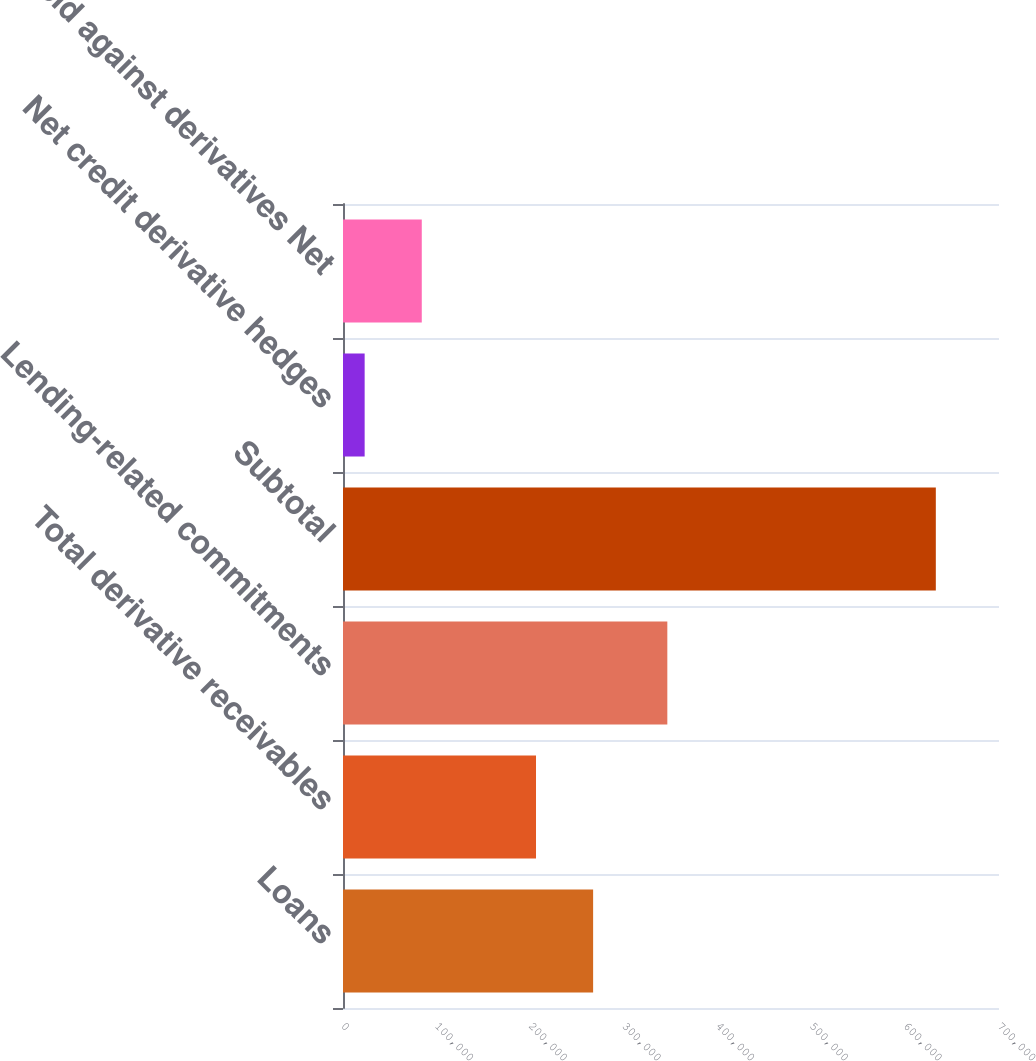Convert chart. <chart><loc_0><loc_0><loc_500><loc_500><bar_chart><fcel>Loans<fcel>Total derivative receivables<fcel>Lending-related commitments<fcel>Subtotal<fcel>Net credit derivative hedges<fcel>held against derivatives Net<nl><fcel>266898<fcel>205951<fcel>346079<fcel>632584<fcel>23108<fcel>84055.6<nl></chart> 